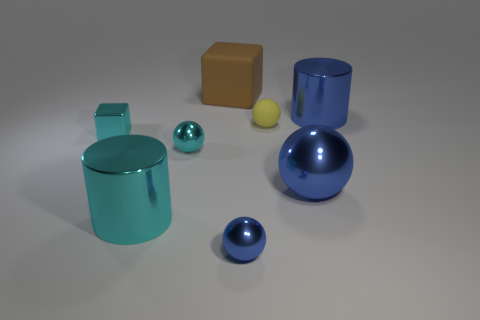Subtract 1 spheres. How many spheres are left? 3 Add 1 brown rubber cubes. How many objects exist? 9 Subtract all cylinders. How many objects are left? 6 Add 5 small cubes. How many small cubes are left? 6 Add 7 matte things. How many matte things exist? 9 Subtract 1 yellow balls. How many objects are left? 7 Subtract all big yellow metal cylinders. Subtract all blue metal spheres. How many objects are left? 6 